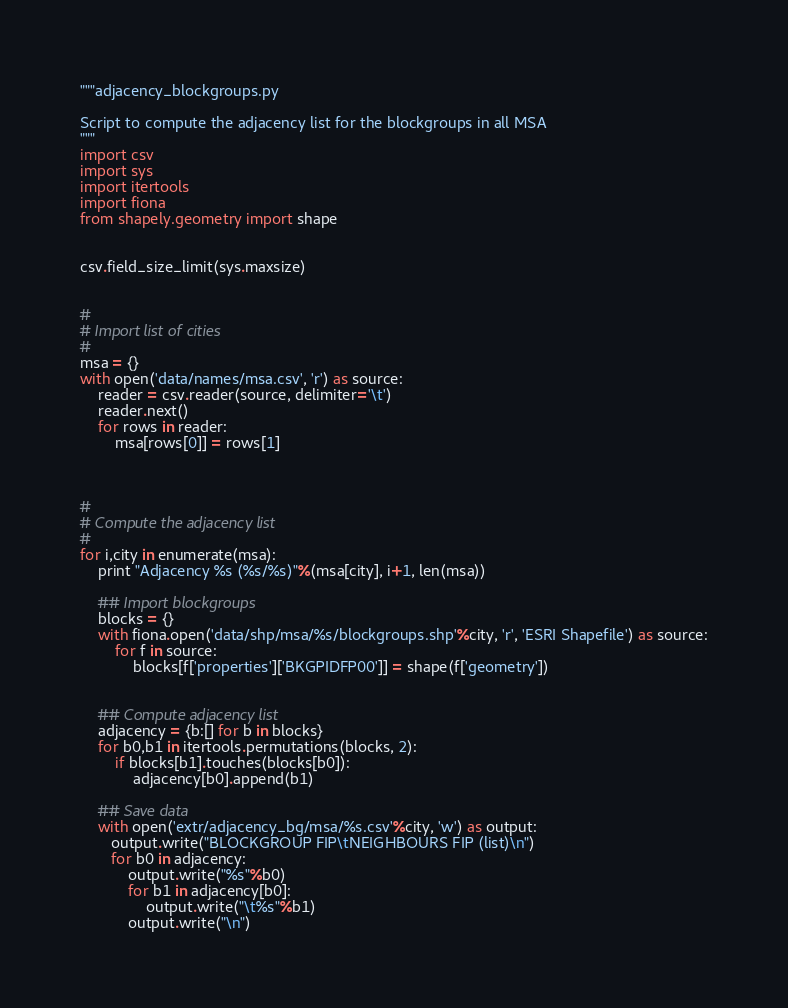<code> <loc_0><loc_0><loc_500><loc_500><_Python_>"""adjacency_blockgroups.py

Script to compute the adjacency list for the blockgroups in all MSA
"""
import csv
import sys
import itertools
import fiona
from shapely.geometry import shape


csv.field_size_limit(sys.maxsize)


#
# Import list of cities 
#
msa = {}
with open('data/names/msa.csv', 'r') as source:
    reader = csv.reader(source, delimiter='\t')
    reader.next()
    for rows in reader:
        msa[rows[0]] = rows[1]



#
# Compute the adjacency list
#
for i,city in enumerate(msa):
    print "Adjacency %s (%s/%s)"%(msa[city], i+1, len(msa))

    ## Import blockgroups
    blocks = {}
    with fiona.open('data/shp/msa/%s/blockgroups.shp'%city, 'r', 'ESRI Shapefile') as source:
        for f in source:
            blocks[f['properties']['BKGPIDFP00']] = shape(f['geometry'])


    ## Compute adjacency list
    adjacency = {b:[] for b in blocks}
    for b0,b1 in itertools.permutations(blocks, 2):
        if blocks[b1].touches(blocks[b0]):
            adjacency[b0].append(b1)

    ## Save data
    with open('extr/adjacency_bg/msa/%s.csv'%city, 'w') as output:
       output.write("BLOCKGROUP FIP\tNEIGHBOURS FIP (list)\n")
       for b0 in adjacency:
           output.write("%s"%b0)
           for b1 in adjacency[b0]:
               output.write("\t%s"%b1)
           output.write("\n")
</code> 